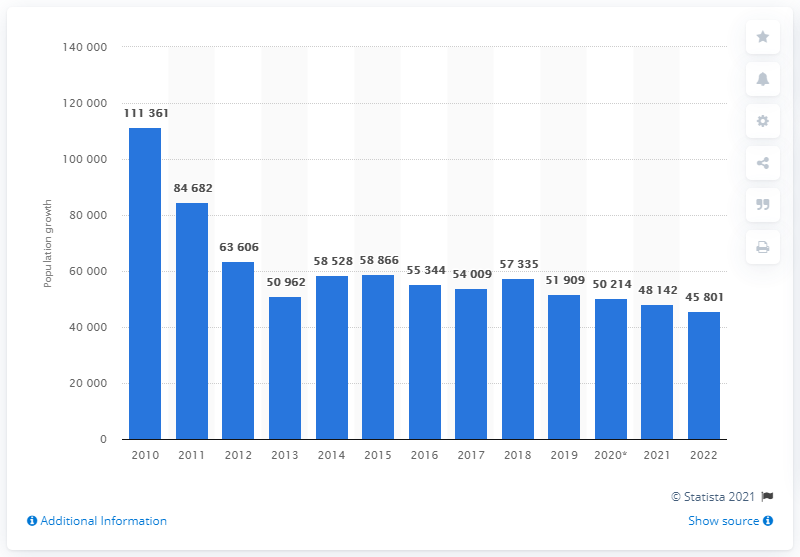Specify some key components in this picture. In 2019, the number of people living in Belgium was approximately 519,090. The population forecast was expected to grow by 51,909 people in 2022. 